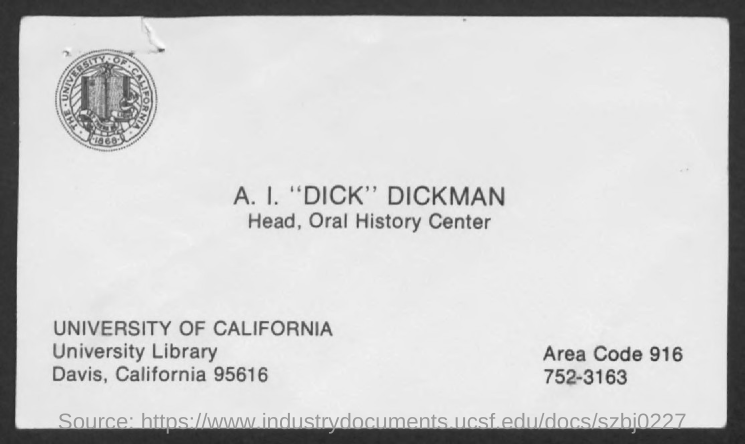Identify some key points in this picture. A. I. "Dick" Dickman is the head of the oral history center. The location of the University of California, Davis is in Davis, California, as indicated by the postal code of 95616. The letter is addressed to "I. "DICK" DICKMAN. The area code is 916.. 